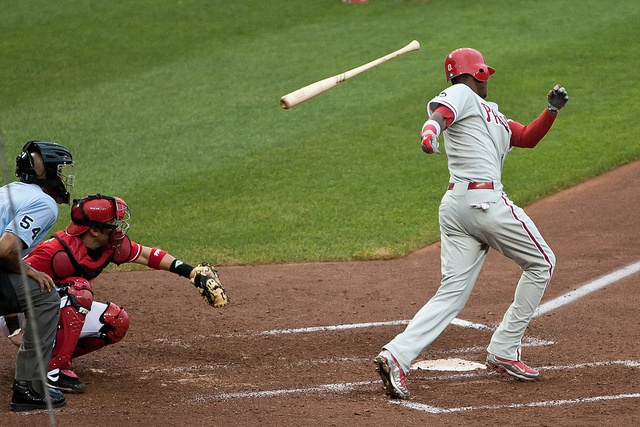Describe the objects in this image and their specific colors. I can see people in darkgreen, lightgray, darkgray, gray, and maroon tones, people in darkgreen, black, maroon, and brown tones, people in darkgreen, black, gray, and lightblue tones, baseball bat in darkgreen, ivory, tan, and olive tones, and baseball glove in darkgreen, black, gray, and tan tones in this image. 